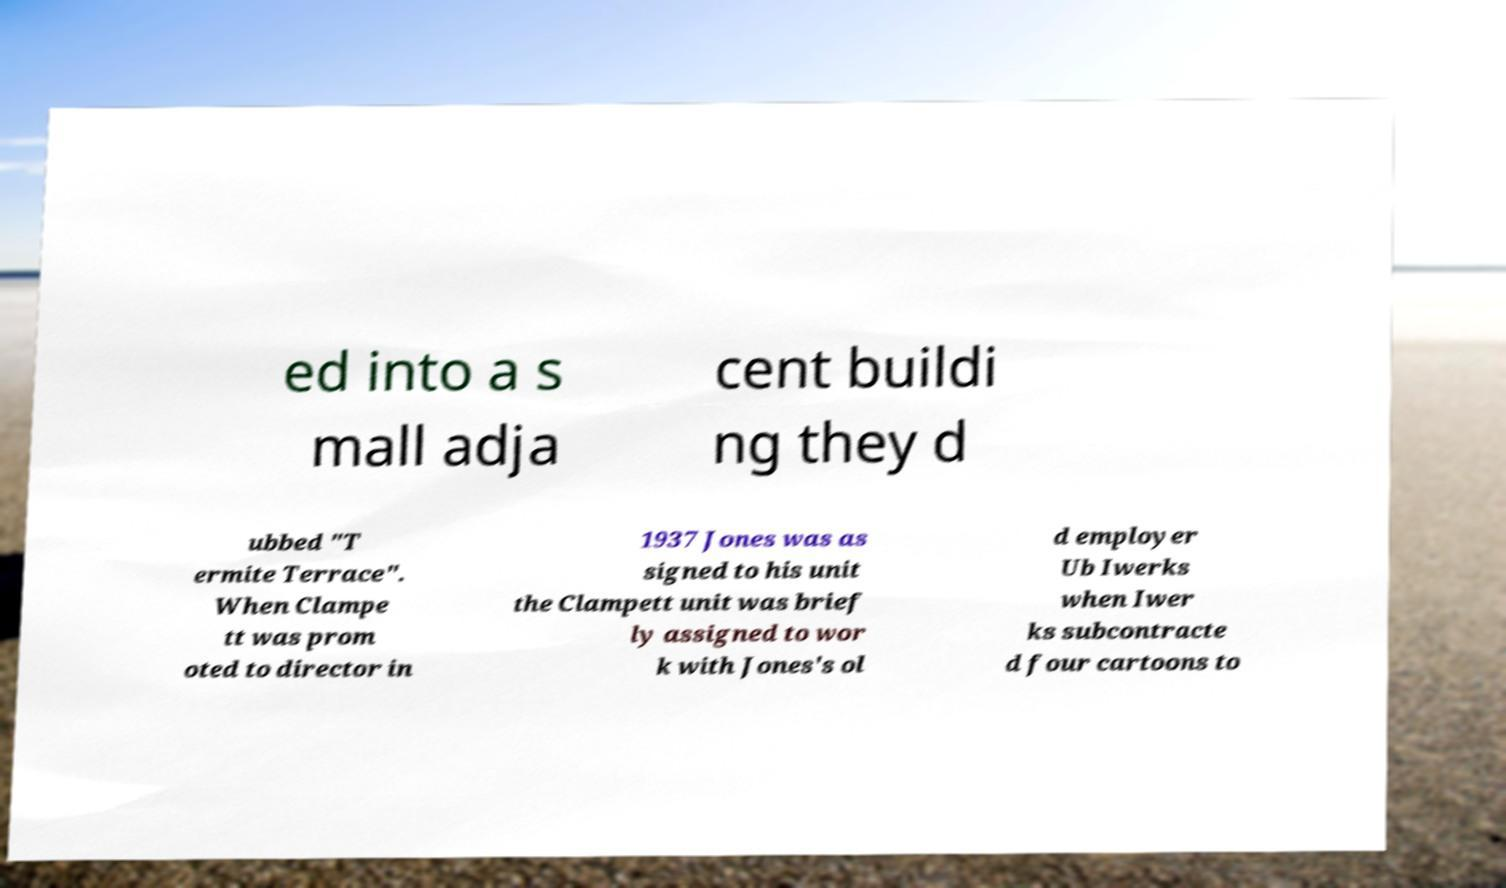Please read and relay the text visible in this image. What does it say? ed into a s mall adja cent buildi ng they d ubbed "T ermite Terrace". When Clampe tt was prom oted to director in 1937 Jones was as signed to his unit the Clampett unit was brief ly assigned to wor k with Jones's ol d employer Ub Iwerks when Iwer ks subcontracte d four cartoons to 